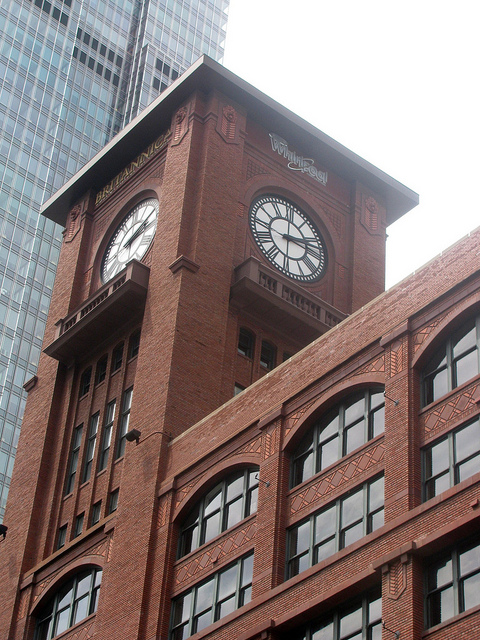Read and extract the text from this image. Whirlpool I II III V XI X X VIII IV VI VII I III XII 